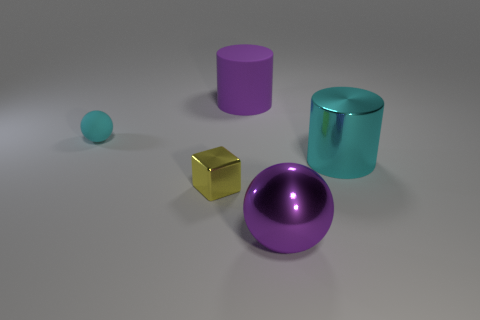There is a cyan rubber object that is the same shape as the purple metallic thing; what is its size?
Keep it short and to the point. Small. There is a big cylinder that is the same color as the big sphere; what material is it?
Your response must be concise. Rubber. There is a ball that is to the left of the purple cylinder; what material is it?
Give a very brief answer. Rubber. The cylinder that is the same color as the big shiny sphere is what size?
Provide a succinct answer. Large. Are there any purple shiny objects that have the same size as the purple sphere?
Keep it short and to the point. No. There is a big cyan thing; is it the same shape as the big purple object to the left of the large purple metal ball?
Your answer should be compact. Yes. There is a metal thing in front of the metallic block; does it have the same size as the purple object behind the yellow block?
Ensure brevity in your answer.  Yes. What number of other things are the same shape as the tiny cyan object?
Ensure brevity in your answer.  1. There is a sphere in front of the large cylinder on the right side of the large purple cylinder; what is it made of?
Offer a very short reply. Metal. What number of rubber things are large brown things or cyan balls?
Keep it short and to the point. 1. 